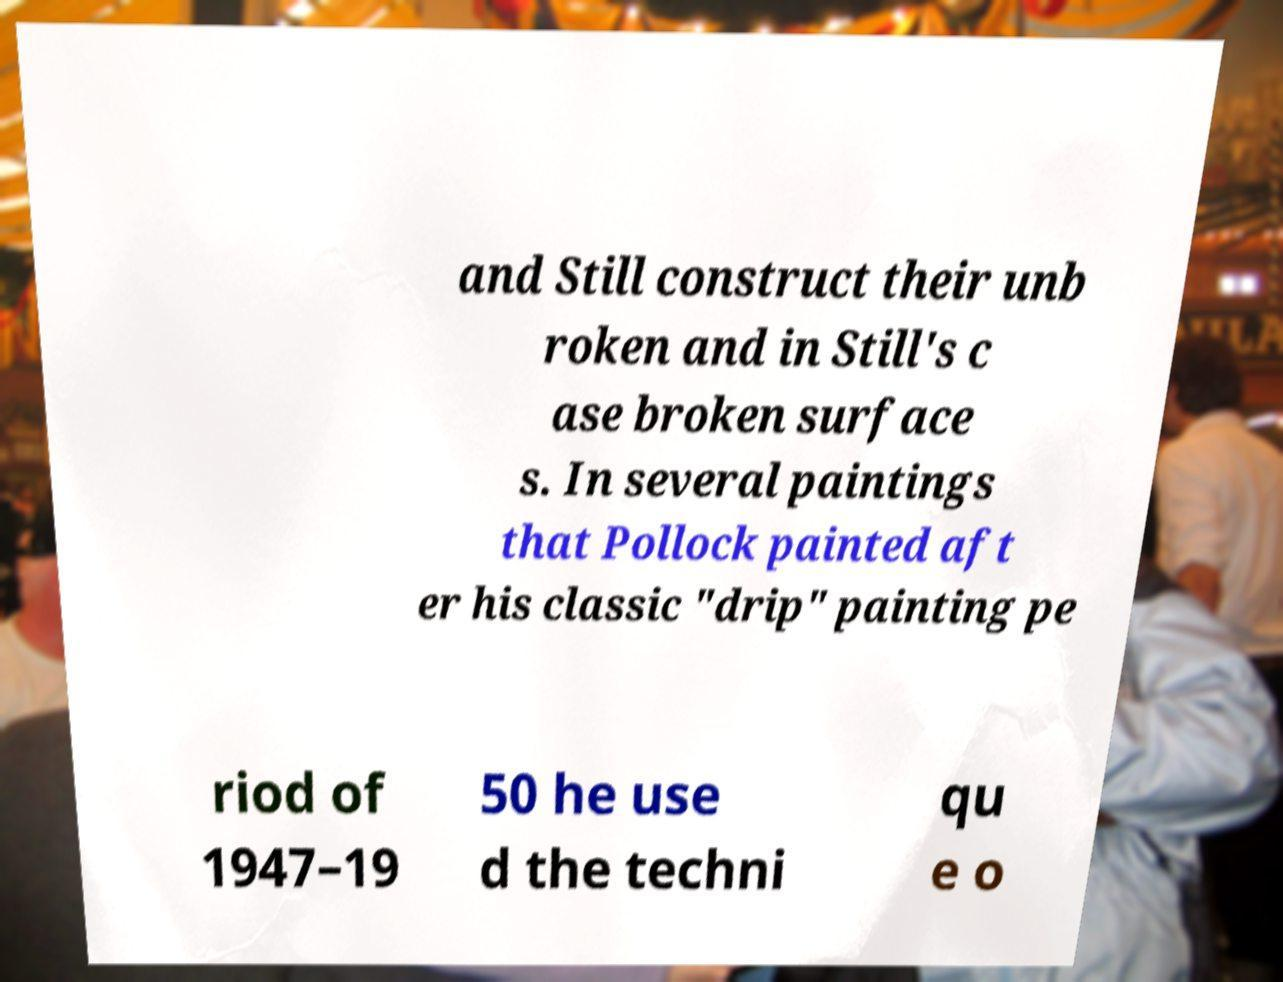Please identify and transcribe the text found in this image. and Still construct their unb roken and in Still's c ase broken surface s. In several paintings that Pollock painted aft er his classic "drip" painting pe riod of 1947–19 50 he use d the techni qu e o 